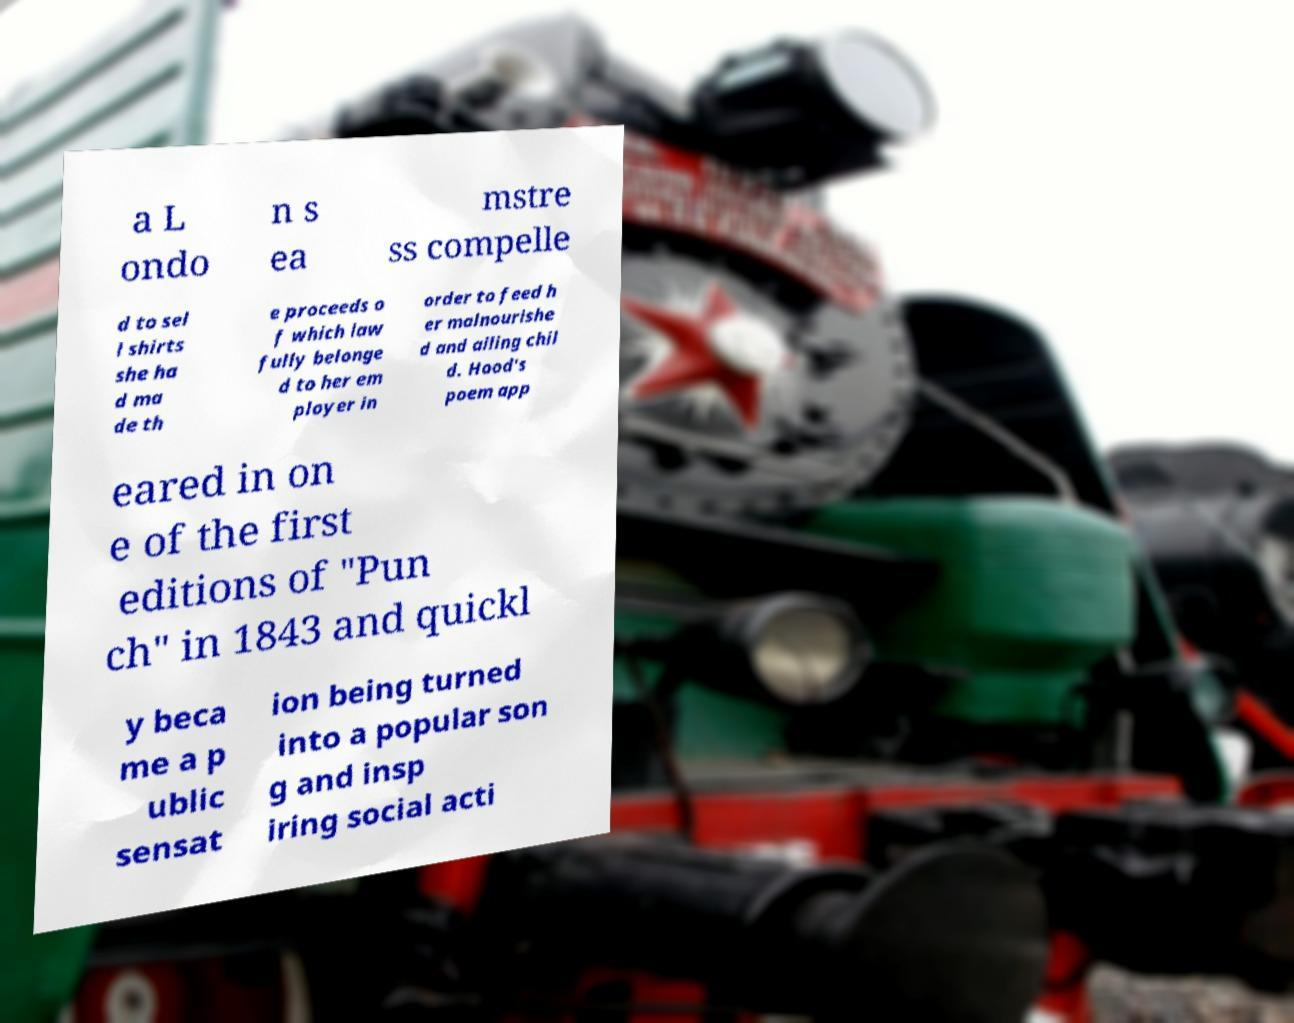Can you accurately transcribe the text from the provided image for me? a L ondo n s ea mstre ss compelle d to sel l shirts she ha d ma de th e proceeds o f which law fully belonge d to her em ployer in order to feed h er malnourishe d and ailing chil d. Hood's poem app eared in on e of the first editions of "Pun ch" in 1843 and quickl y beca me a p ublic sensat ion being turned into a popular son g and insp iring social acti 